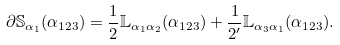Convert formula to latex. <formula><loc_0><loc_0><loc_500><loc_500>\partial \mathbb { S } _ { \alpha _ { 1 } } ( \alpha _ { 1 2 3 } ) = \frac { 1 } { 2 } \mathbb { L } _ { \alpha _ { 1 } \alpha _ { 2 } } ( \alpha _ { 1 2 3 } ) + \frac { 1 } { 2 ^ { \prime } } \mathbb { L } _ { \alpha _ { 3 } \alpha _ { 1 } } ( \alpha _ { 1 2 3 } ) .</formula> 